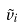<formula> <loc_0><loc_0><loc_500><loc_500>\tilde { v } _ { i }</formula> 